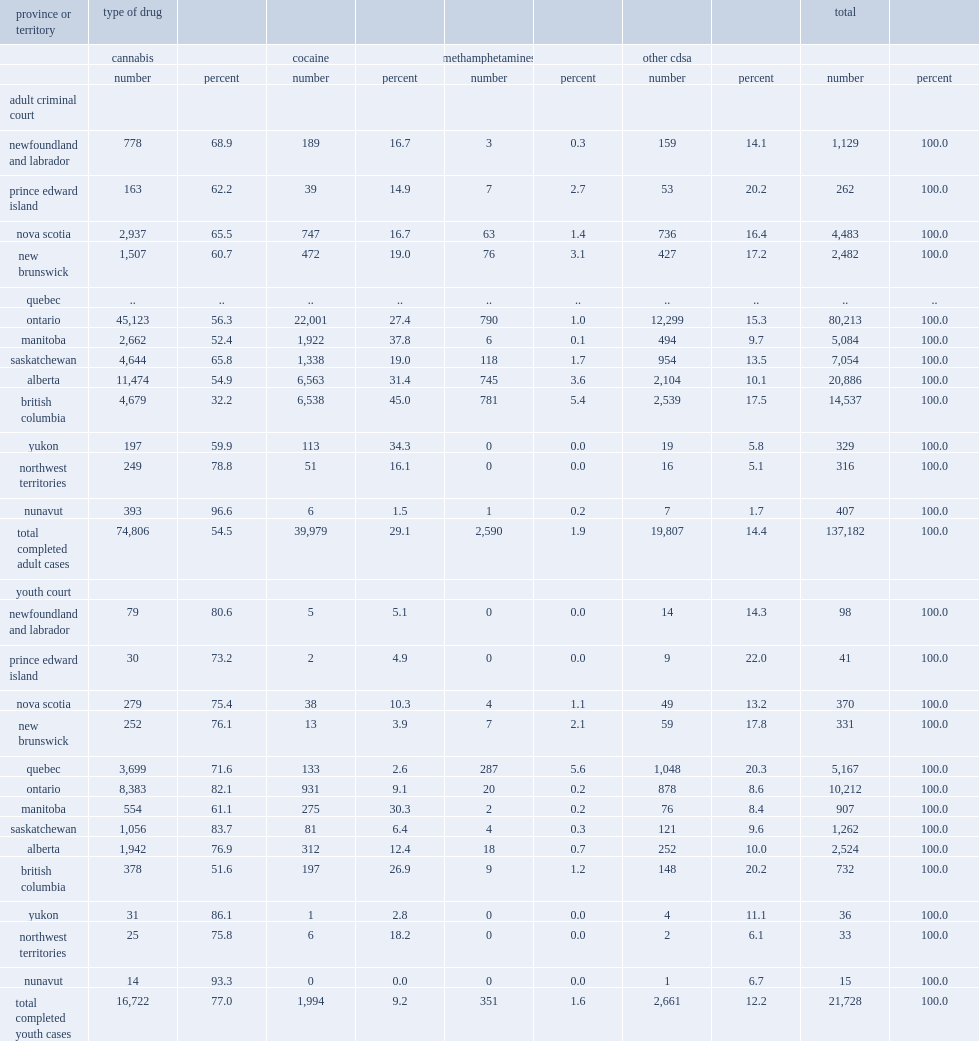Cannabis-related cases accounted for more than half of all completed drug-related cases in adult criminal court in each province, with the exception of british columbia, what is the percentage of completed drug-related cases involved cannabis of this province from 2008/2009 to 2011/2012? 32.2. Among the provinces, what is the proportion of completed drug-related cases involving cannabis in adult criminal court in newfoundland and labrador from 2008/2009 to 2011/2012? 68.9. Among the provinces, what is the proportion of completed drug-related cases involving cannabis in adult criminal court in saskatchewan from 2008/2009 to 2011/2012? 65.8. Among the provinces, what is the proportion of completed drug-related cases involving cannabis in adult criminal court in nova scotia from 2008/2009 to 2011/2012? 65.5. 